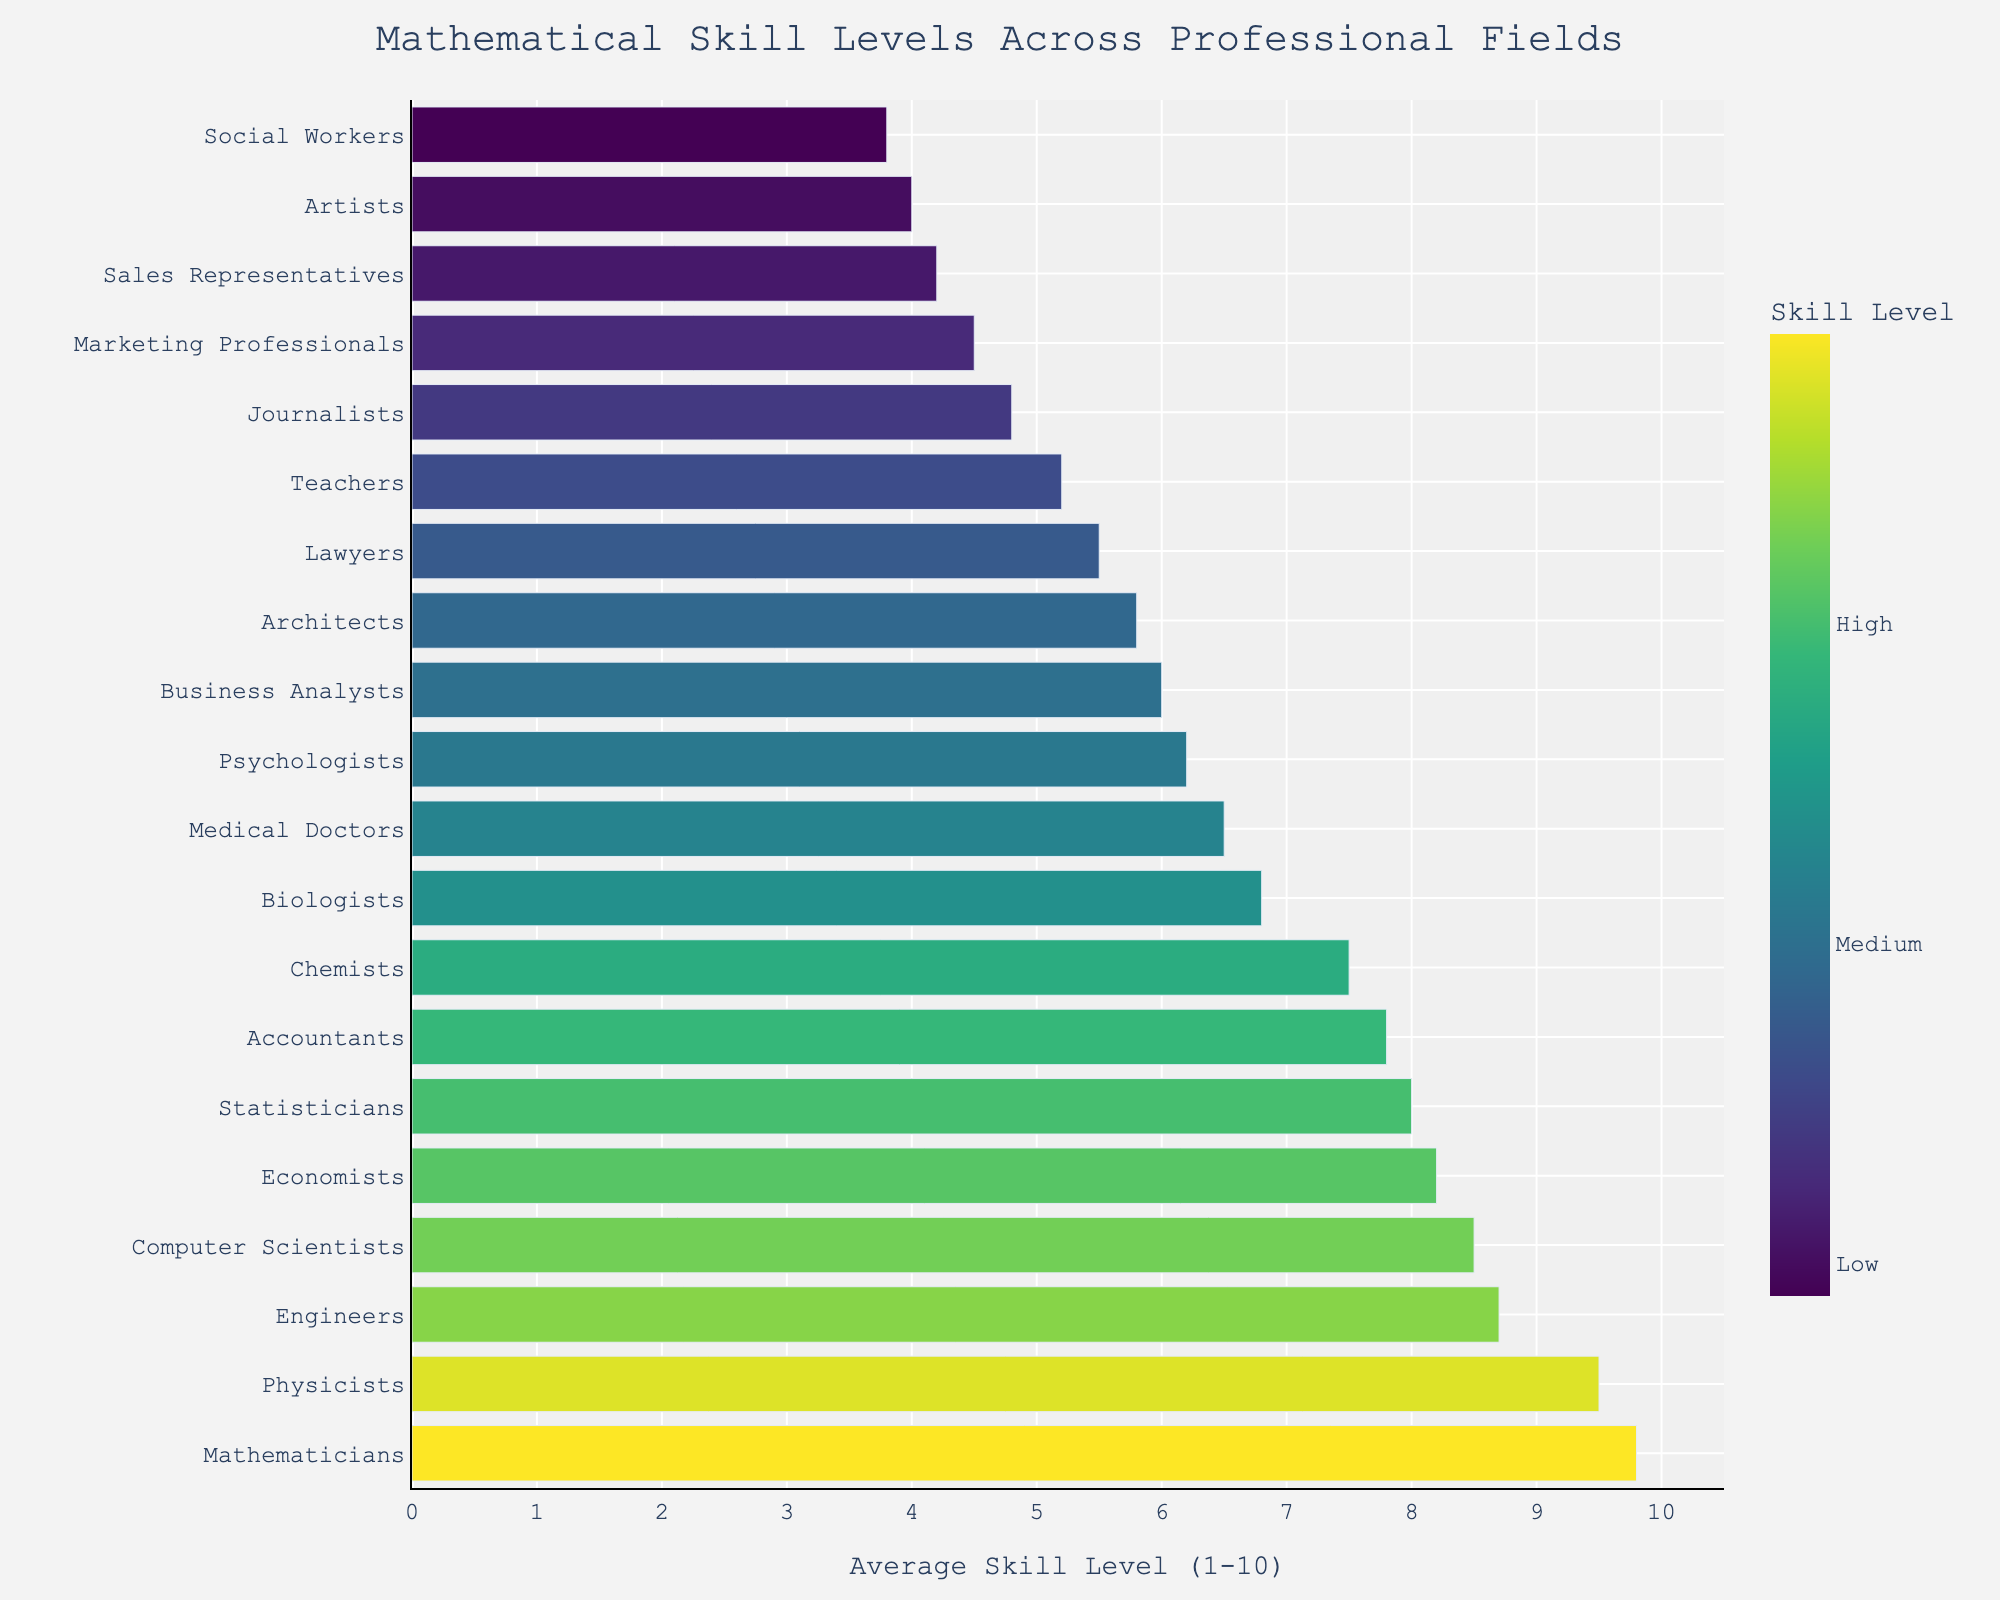What professional field has the highest average mathematical skill level? Mathematicians are at the top of the chart with an average mathematical skill level of 9.8, as indicated by the length of the bar.
Answer: Mathematicians What is the difference in average mathematical skill level between Mathematicians and Business Analysts? Mathematicians have an average skill level of 9.8, while Business Analysts have 6. Hence, the difference is 9.8 - 6 = 3.8.
Answer: 3.8 Which group, Computer Scientists or Chemists, has a higher average mathematical skill level and by how much? Computer Scientists have an 8.5 skill level, while Chemists have 7.5. Subtracting them, 8.5 - 7.5 gives us the difference.
Answer: Computer Scientists by 1.0 What is the combined average skill level of Engineers, Economists, and Statisticians? Engineers have 8.7, Economists have 8.2, and Statisticians have 8. Summing these up, 8.7 + 8.2 + 8 = 24.9.
Answer: 24.9 Are there more fields with an average skill level above 8 or below 6? By counting the bars, there are 4 fields above 8 and 7 fields below 6.
Answer: More fields below 6 Where do Physicists rank in terms of average mathematical skill levels among the shown professional fields? Physicists are second from the top in the chart, right below Mathematicians.
Answer: 2nd What proportion of all the fields have an average mathematical skill level of 7 or higher? There are 7 fields with a skill level of 7 or higher out of a total of 20 fields. Thus, the proportion is 7/20.
Answer: 0.35 (or 35%) How does the mathematical skill level of Architects compare to Lawyers? Architects have an average skill level of 5.8 while Lawyers have 5.5, so Architects are slightly higher.
Answer: Architects are higher by 0.3 Which field has a skill level closest to 5, and how is it visually represented in the color bar? Teachers have an average skill level of 5.2, closest to 5. This would appear in a medium shade according to the Viridis color scale.
Answer: Teachers What is the average mathematical skill level for the entire list of professional fields? Sum all the values: (9.8 + 9.5 + 8.7 + 8.5 + 8.2 + 8.0 + 7.8 + 7.5 + 6.8 + 6.5 + 6.2 + 6.0 + 5.8 + 5.5 + 5.2 + 4.8 + 4.5 + 4.2 + 4.0 + 3.8) = 130.3. Divide by the number of fields, 130.3 / 20 = 6.515.
Answer: 6.515 